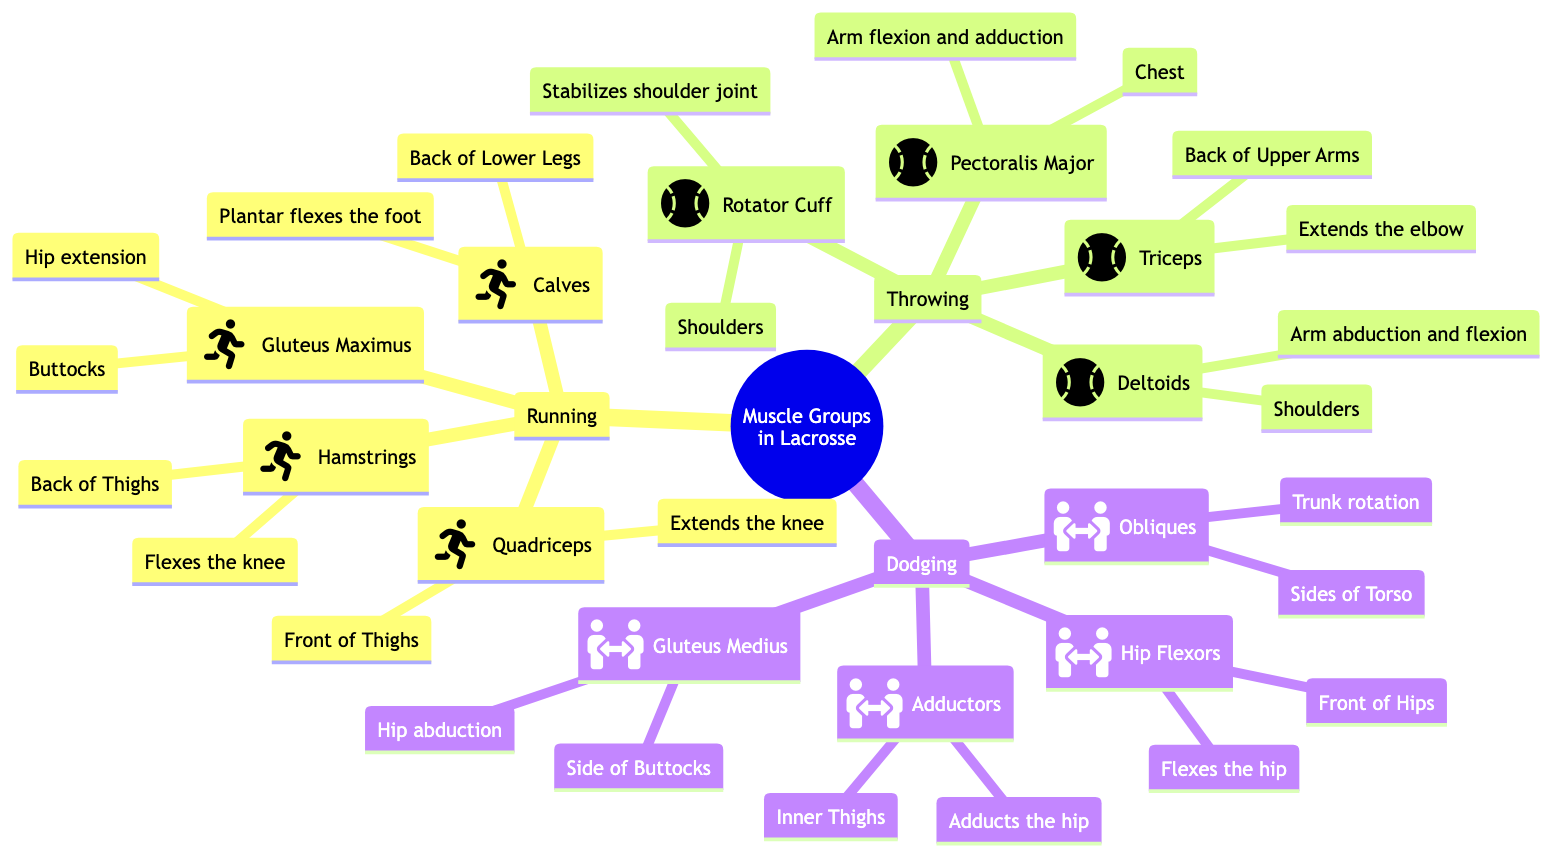What muscle group is primarily engaged in running? The diagram shows that the primary muscle group engaged in running is the Quadriceps. This is found under the "Running" section, which identifies the key muscles involved in this action.
Answer: Quadriceps How many muscle groups are highlighted for throwing? The "Throwing" section of the diagram lists four muscle groups: Rotator Cuff, Deltoids, Pectoralis Major, and Triceps. By counting these, we can determine the total number.
Answer: 4 Which muscle is responsible for trunk rotation during dodging? The diagram under the "Dodging" section indicates that the Obliques are responsible for trunk rotation. This muscle is specifically associated with the action of dodging.
Answer: Obliques What action do the Hip Flexors assist with? The diagram illustrates that the Hip Flexors assist in flexing the hip, which is explicitly mentioned in the description of this muscle group under the "Dodging" section.
Answer: Flexes the hip Which muscle is located at the back of the thighs? In the "Running" section, the Hamstrings are noted to be at the back of the thighs, as indicated by its placement and description in the diagram.
Answer: Hamstrings What is the function of the Gluteus Maximus while running? According to the diagram’s information for the "Running" section, the Gluteus Maximus is associated with hip extension, which defines its role during this action.
Answer: Hip extension How many muscle groups are engaged in dodging? The "Dodging" section lists four muscle groups: Obliques, Hip Flexors, Adductors, and Gluteus Medius. Counting these provides the total engaged in this action.
Answer: 4 Which muscle group stabilizes the shoulder joint during throwing? The diagram shows that the Rotator Cuff is specifically responsible for stabilizing the shoulder joint, as highlighted in the "Throwing" section.
Answer: Rotator Cuff What action is the Deltoids muscle responsible for in throwing? The Deltoids are described in the diagram as responsible for arm abduction and flexion, indicating their key function during throwing.
Answer: Arm abduction and flexion 